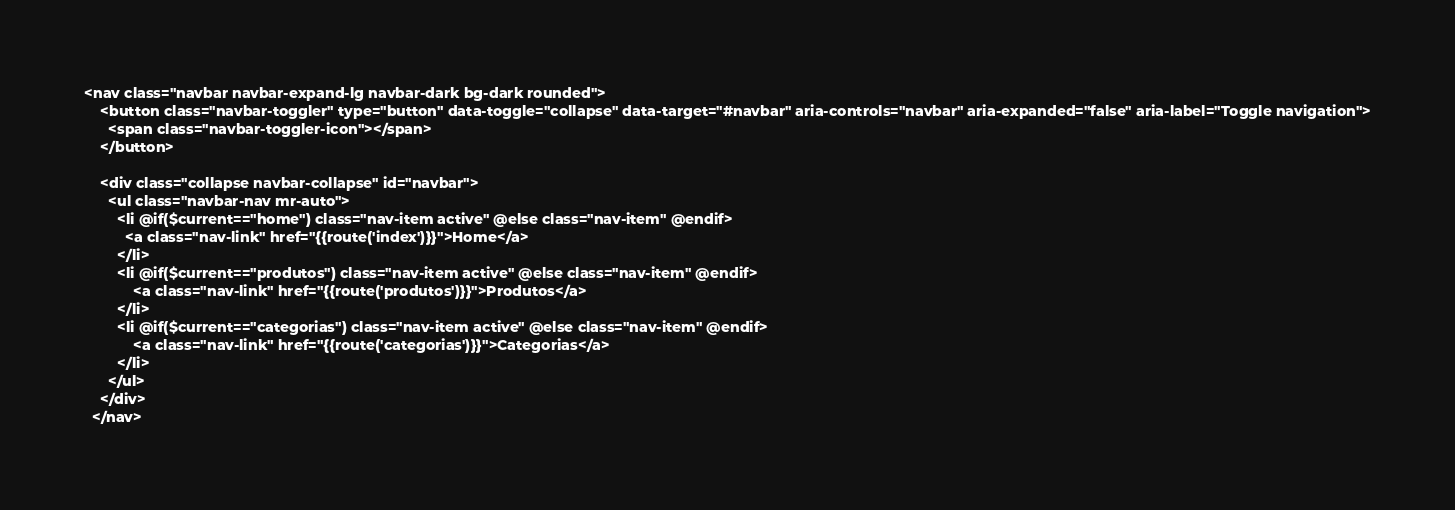Convert code to text. <code><loc_0><loc_0><loc_500><loc_500><_PHP_><nav class="navbar navbar-expand-lg navbar-dark bg-dark rounded">
    <button class="navbar-toggler" type="button" data-toggle="collapse" data-target="#navbar" aria-controls="navbar" aria-expanded="false" aria-label="Toggle navigation">
      <span class="navbar-toggler-icon"></span>
    </button>
  
    <div class="collapse navbar-collapse" id="navbar">
      <ul class="navbar-nav mr-auto">
        <li @if($current=="home") class="nav-item active" @else class="nav-item" @endif>
          <a class="nav-link" href="{{route('index')}}">Home</a>
        </li>
        <li @if($current=="produtos") class="nav-item active" @else class="nav-item" @endif>
            <a class="nav-link" href="{{route('produtos')}}">Produtos</a>
        </li>
        <li @if($current=="categorias") class="nav-item active" @else class="nav-item" @endif>
            <a class="nav-link" href="{{route('categorias')}}">Categorias</a>
        </li>
      </ul>
    </div>
  </nav></code> 